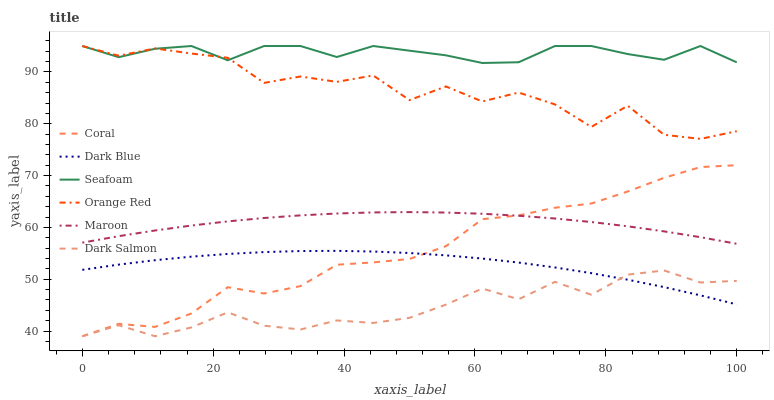Does Dark Salmon have the minimum area under the curve?
Answer yes or no. Yes. Does Seafoam have the maximum area under the curve?
Answer yes or no. Yes. Does Maroon have the minimum area under the curve?
Answer yes or no. No. Does Maroon have the maximum area under the curve?
Answer yes or no. No. Is Maroon the smoothest?
Answer yes or no. Yes. Is Orange Red the roughest?
Answer yes or no. Yes. Is Dark Salmon the smoothest?
Answer yes or no. No. Is Dark Salmon the roughest?
Answer yes or no. No. Does Maroon have the lowest value?
Answer yes or no. No. Does Orange Red have the highest value?
Answer yes or no. Yes. Does Maroon have the highest value?
Answer yes or no. No. Is Maroon less than Seafoam?
Answer yes or no. Yes. Is Orange Red greater than Dark Salmon?
Answer yes or no. Yes. Does Coral intersect Dark Blue?
Answer yes or no. Yes. Is Coral less than Dark Blue?
Answer yes or no. No. Is Coral greater than Dark Blue?
Answer yes or no. No. Does Maroon intersect Seafoam?
Answer yes or no. No. 